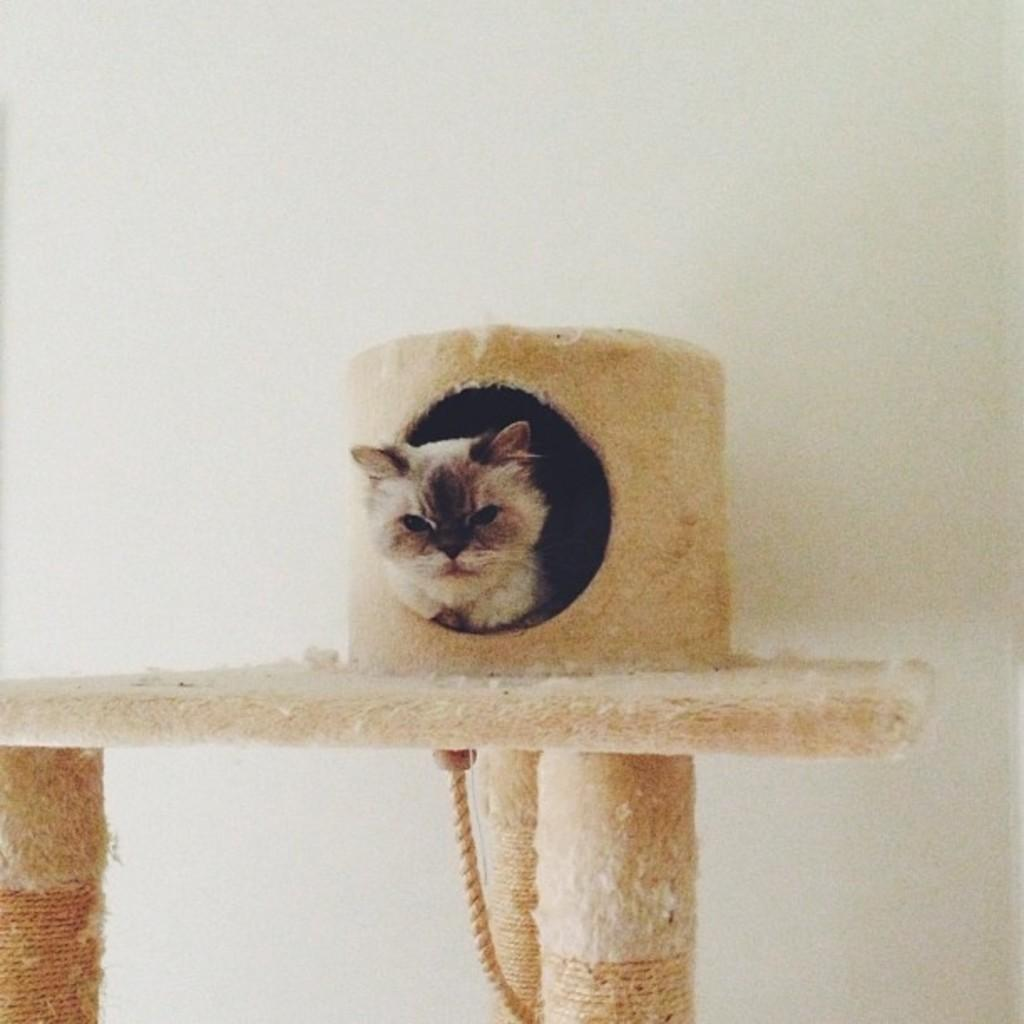What animal is inside the hole in the image? There is a cat inside a hole in the image. What can be seen under the surface in the image? There is a rope under the surface in the image. What color is the wall in the background of the image? The wall in the background of the image is white. What type of plants can be seen growing on the curve in the image? There are no plants or curves present in the image; it features a cat inside a hole, a rope under the surface, and a white wall in the background. 